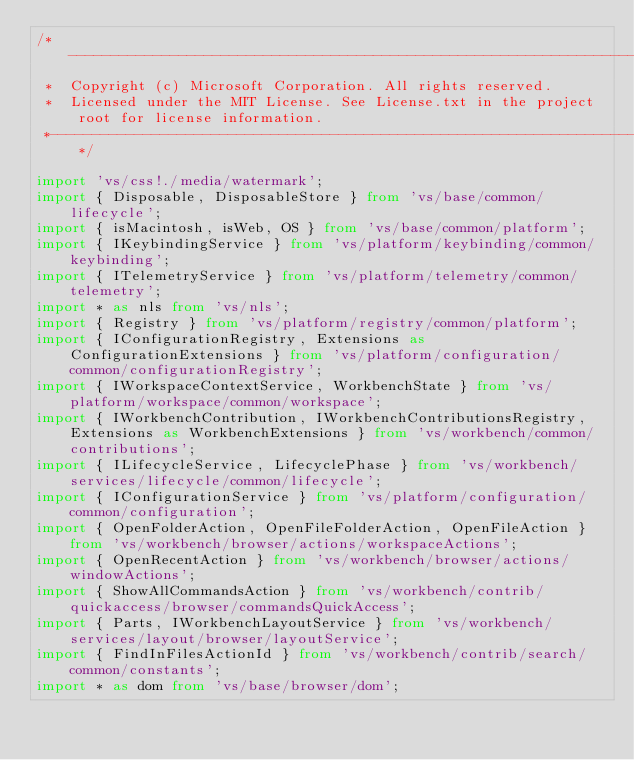Convert code to text. <code><loc_0><loc_0><loc_500><loc_500><_TypeScript_>/*---------------------------------------------------------------------------------------------
 *  Copyright (c) Microsoft Corporation. All rights reserved.
 *  Licensed under the MIT License. See License.txt in the project root for license information.
 *--------------------------------------------------------------------------------------------*/

import 'vs/css!./media/watermark';
import { Disposable, DisposableStore } from 'vs/base/common/lifecycle';
import { isMacintosh, isWeb, OS } from 'vs/base/common/platform';
import { IKeybindingService } from 'vs/platform/keybinding/common/keybinding';
import { ITelemetryService } from 'vs/platform/telemetry/common/telemetry';
import * as nls from 'vs/nls';
import { Registry } from 'vs/platform/registry/common/platform';
import { IConfigurationRegistry, Extensions as ConfigurationExtensions } from 'vs/platform/configuration/common/configurationRegistry';
import { IWorkspaceContextService, WorkbenchState } from 'vs/platform/workspace/common/workspace';
import { IWorkbenchContribution, IWorkbenchContributionsRegistry, Extensions as WorkbenchExtensions } from 'vs/workbench/common/contributions';
import { ILifecycleService, LifecyclePhase } from 'vs/workbench/services/lifecycle/common/lifecycle';
import { IConfigurationService } from 'vs/platform/configuration/common/configuration';
import { OpenFolderAction, OpenFileFolderAction, OpenFileAction } from 'vs/workbench/browser/actions/workspaceActions';
import { OpenRecentAction } from 'vs/workbench/browser/actions/windowActions';
import { ShowAllCommandsAction } from 'vs/workbench/contrib/quickaccess/browser/commandsQuickAccess';
import { Parts, IWorkbenchLayoutService } from 'vs/workbench/services/layout/browser/layoutService';
import { FindInFilesActionId } from 'vs/workbench/contrib/search/common/constants';
import * as dom from 'vs/base/browser/dom';</code> 